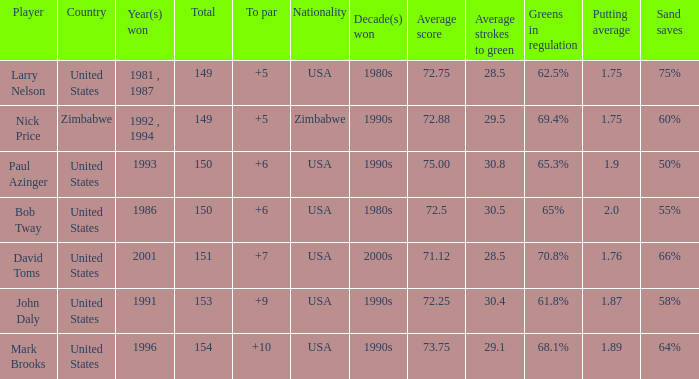How many to pars were won in 1993? 1.0. 